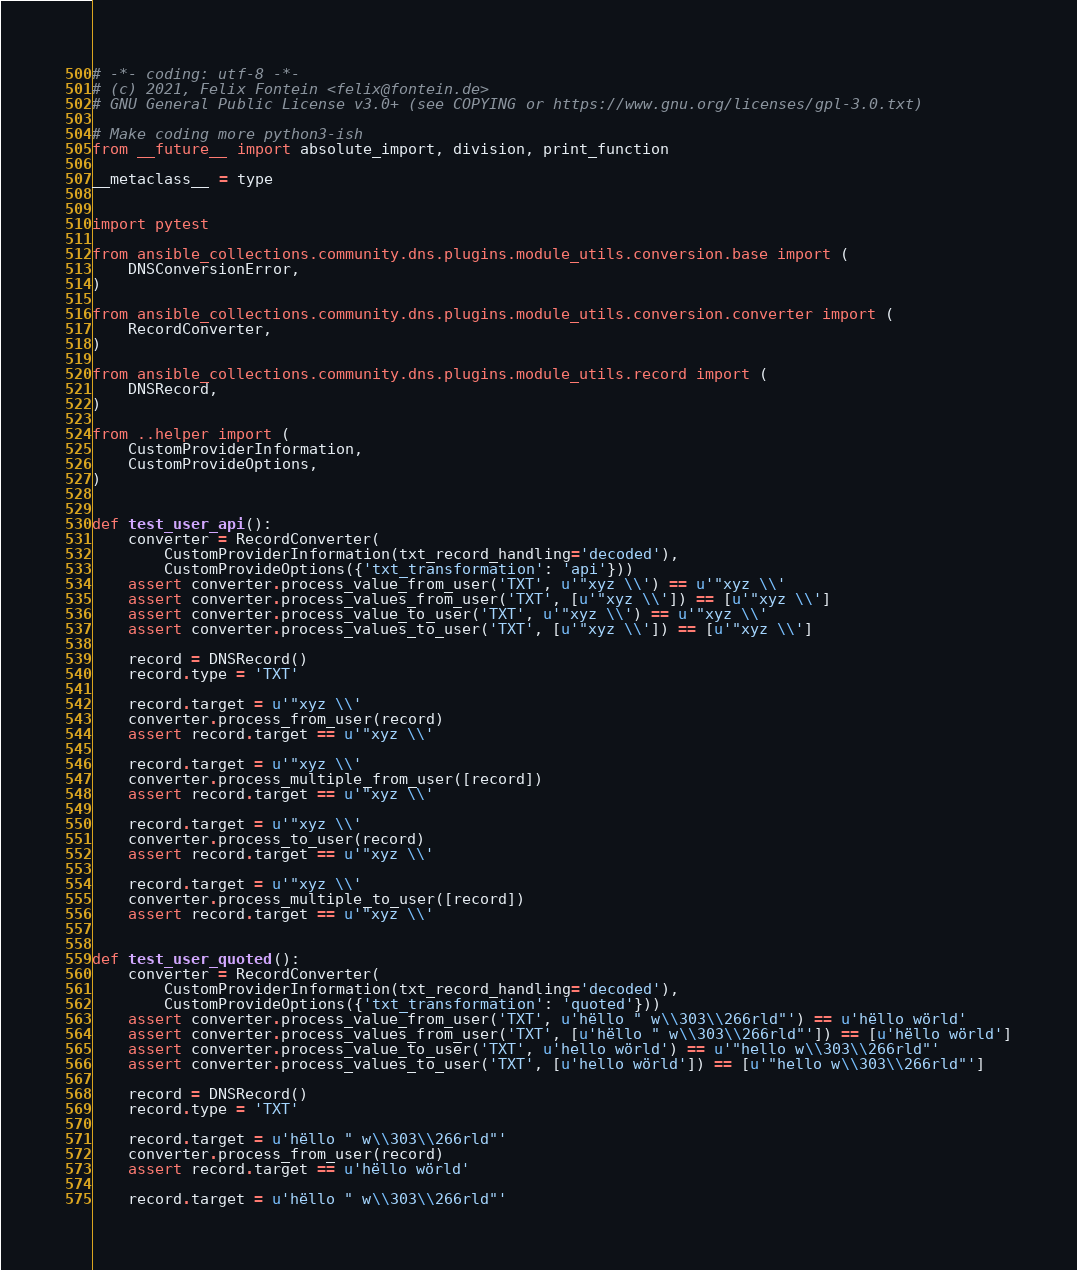Convert code to text. <code><loc_0><loc_0><loc_500><loc_500><_Python_># -*- coding: utf-8 -*-
# (c) 2021, Felix Fontein <felix@fontein.de>
# GNU General Public License v3.0+ (see COPYING or https://www.gnu.org/licenses/gpl-3.0.txt)

# Make coding more python3-ish
from __future__ import absolute_import, division, print_function

__metaclass__ = type


import pytest

from ansible_collections.community.dns.plugins.module_utils.conversion.base import (
    DNSConversionError,
)

from ansible_collections.community.dns.plugins.module_utils.conversion.converter import (
    RecordConverter,
)

from ansible_collections.community.dns.plugins.module_utils.record import (
    DNSRecord,
)

from ..helper import (
    CustomProviderInformation,
    CustomProvideOptions,
)


def test_user_api():
    converter = RecordConverter(
        CustomProviderInformation(txt_record_handling='decoded'),
        CustomProvideOptions({'txt_transformation': 'api'}))
    assert converter.process_value_from_user('TXT', u'"xyz \\') == u'"xyz \\'
    assert converter.process_values_from_user('TXT', [u'"xyz \\']) == [u'"xyz \\']
    assert converter.process_value_to_user('TXT', u'"xyz \\') == u'"xyz \\'
    assert converter.process_values_to_user('TXT', [u'"xyz \\']) == [u'"xyz \\']

    record = DNSRecord()
    record.type = 'TXT'

    record.target = u'"xyz \\'
    converter.process_from_user(record)
    assert record.target == u'"xyz \\'

    record.target = u'"xyz \\'
    converter.process_multiple_from_user([record])
    assert record.target == u'"xyz \\'

    record.target = u'"xyz \\'
    converter.process_to_user(record)
    assert record.target == u'"xyz \\'

    record.target = u'"xyz \\'
    converter.process_multiple_to_user([record])
    assert record.target == u'"xyz \\'


def test_user_quoted():
    converter = RecordConverter(
        CustomProviderInformation(txt_record_handling='decoded'),
        CustomProvideOptions({'txt_transformation': 'quoted'}))
    assert converter.process_value_from_user('TXT', u'hëllo " w\\303\\266rld"') == u'hëllo wörld'
    assert converter.process_values_from_user('TXT', [u'hëllo " w\\303\\266rld"']) == [u'hëllo wörld']
    assert converter.process_value_to_user('TXT', u'hello wörld') == u'"hello w\\303\\266rld"'
    assert converter.process_values_to_user('TXT', [u'hello wörld']) == [u'"hello w\\303\\266rld"']

    record = DNSRecord()
    record.type = 'TXT'

    record.target = u'hëllo " w\\303\\266rld"'
    converter.process_from_user(record)
    assert record.target == u'hëllo wörld'

    record.target = u'hëllo " w\\303\\266rld"'</code> 